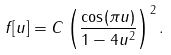<formula> <loc_0><loc_0><loc_500><loc_500>f [ u ] = C \left ( \frac { \cos ( \pi u ) } { 1 - 4 u ^ { 2 } } \right ) ^ { 2 } .</formula> 